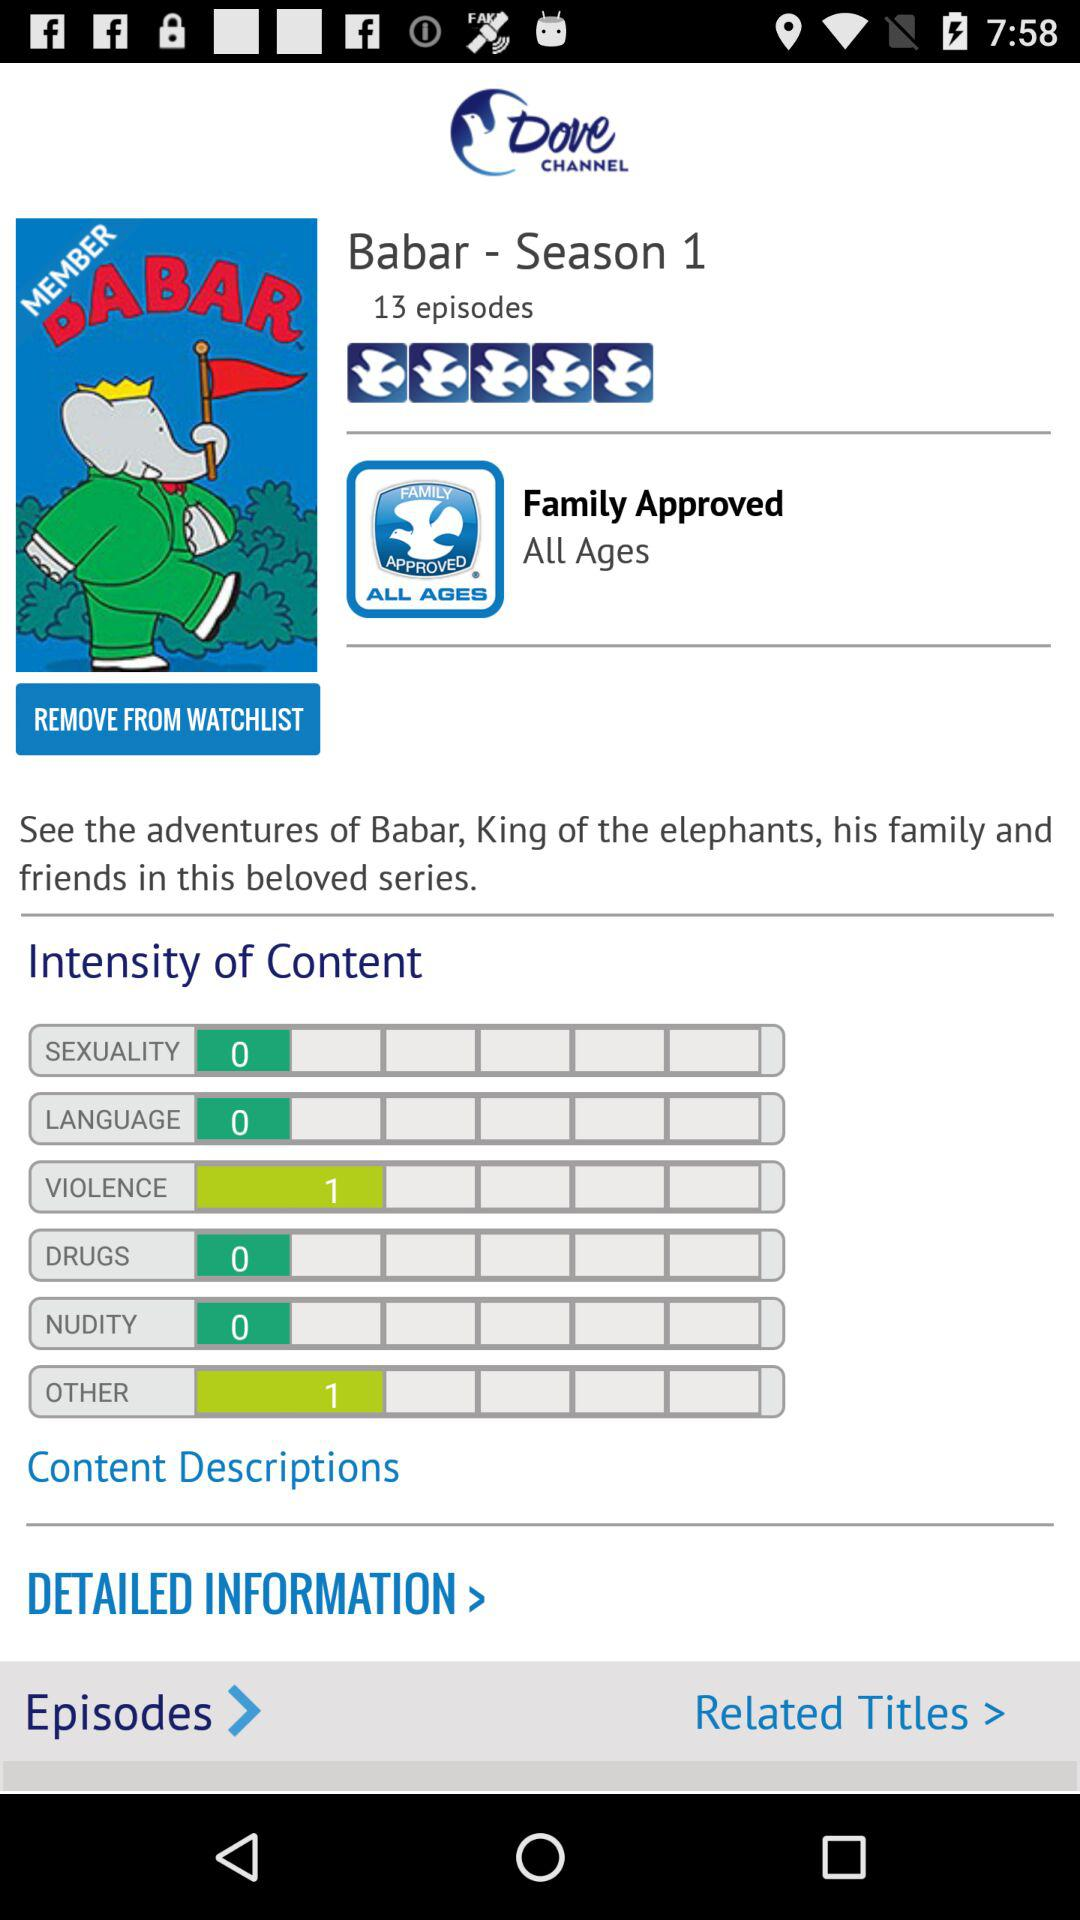What is the intensity of the violence content in Babar - Season 1? The intensity of the violence content in Babar - Season 1 is 1. 